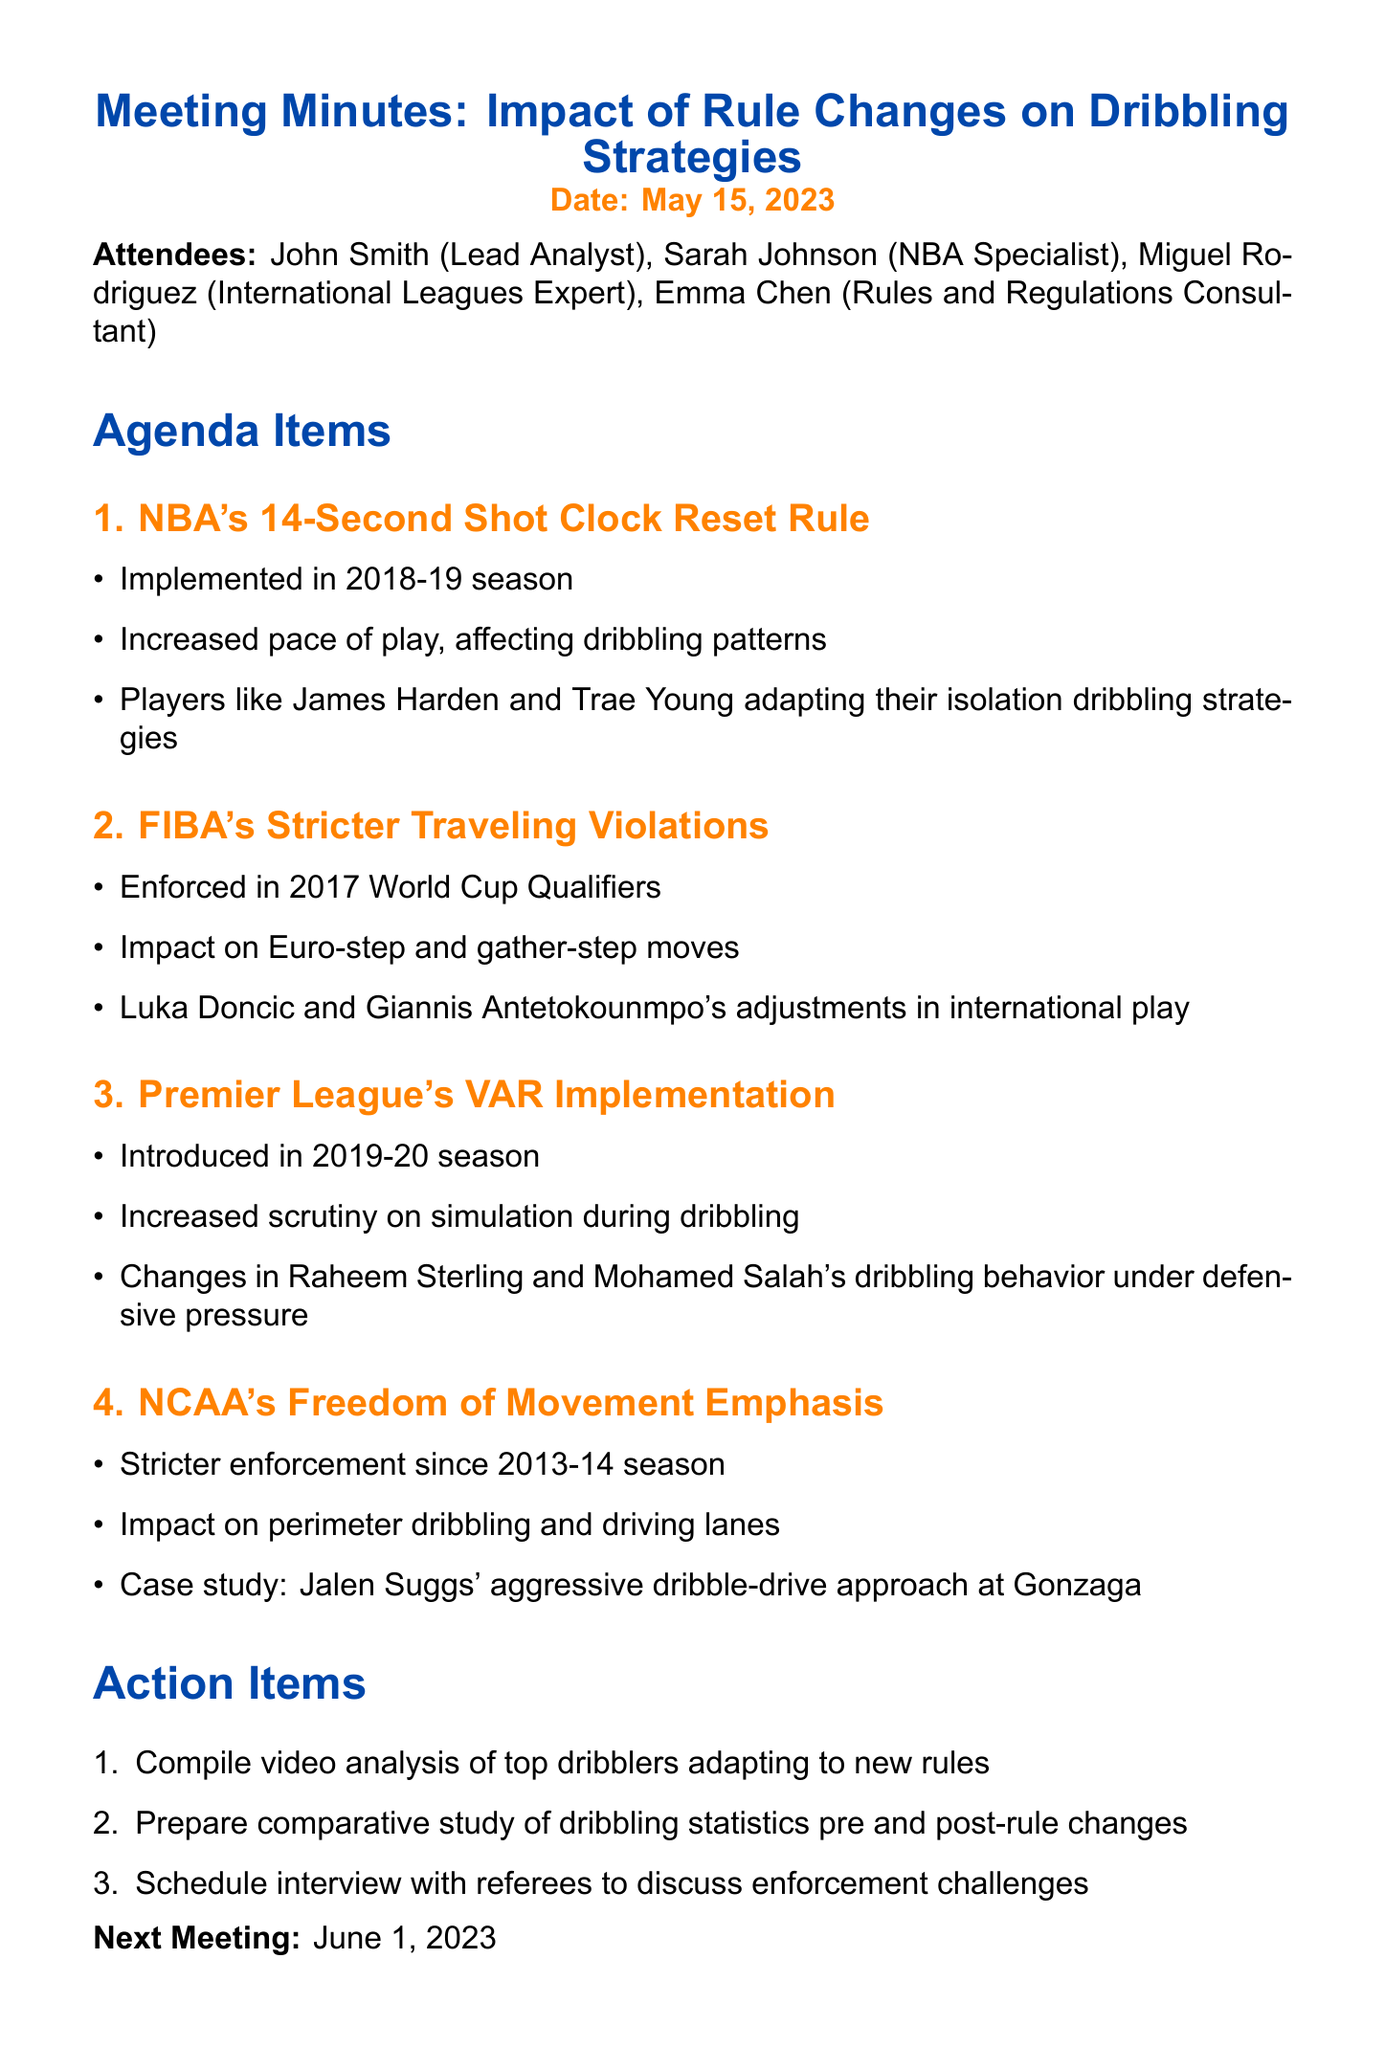What is the date of the meeting? The date of the meeting is explicitly mentioned at the top of the document.
Answer: May 15, 2023 Who is the lead analyst in the meeting? The document lists John Smith as the lead analyst among the attendees.
Answer: John Smith Which NBA players are mentioned regarding the 14-second shot clock reset rule? The document specifically names two players who are adapting their strategies due to this rule.
Answer: James Harden and Trae Young In what season was FIBA's stricter traveling violations enforced? The document states that this enforcement began during a specific tournament period.
Answer: 2017 World Cup Qualifiers What is one impact of the NCAA's freedom of movement emphasis mentioned in the document? The document indicates that this emphasis has affected a particular aspect of play.
Answer: Impact on perimeter dribbling and driving lanes How many action items are listed in the document? The action items are enumerated in a list, providing a clear count.
Answer: Three Which Premier League players are cited in context of VAR implementation? The document identifies two players whose dribbling behavior changed due to VAR.
Answer: Raheem Sterling and Mohamed Salah When is the next meeting scheduled? The document provides a specific date for the upcoming meeting at the end.
Answer: June 1, 2023 